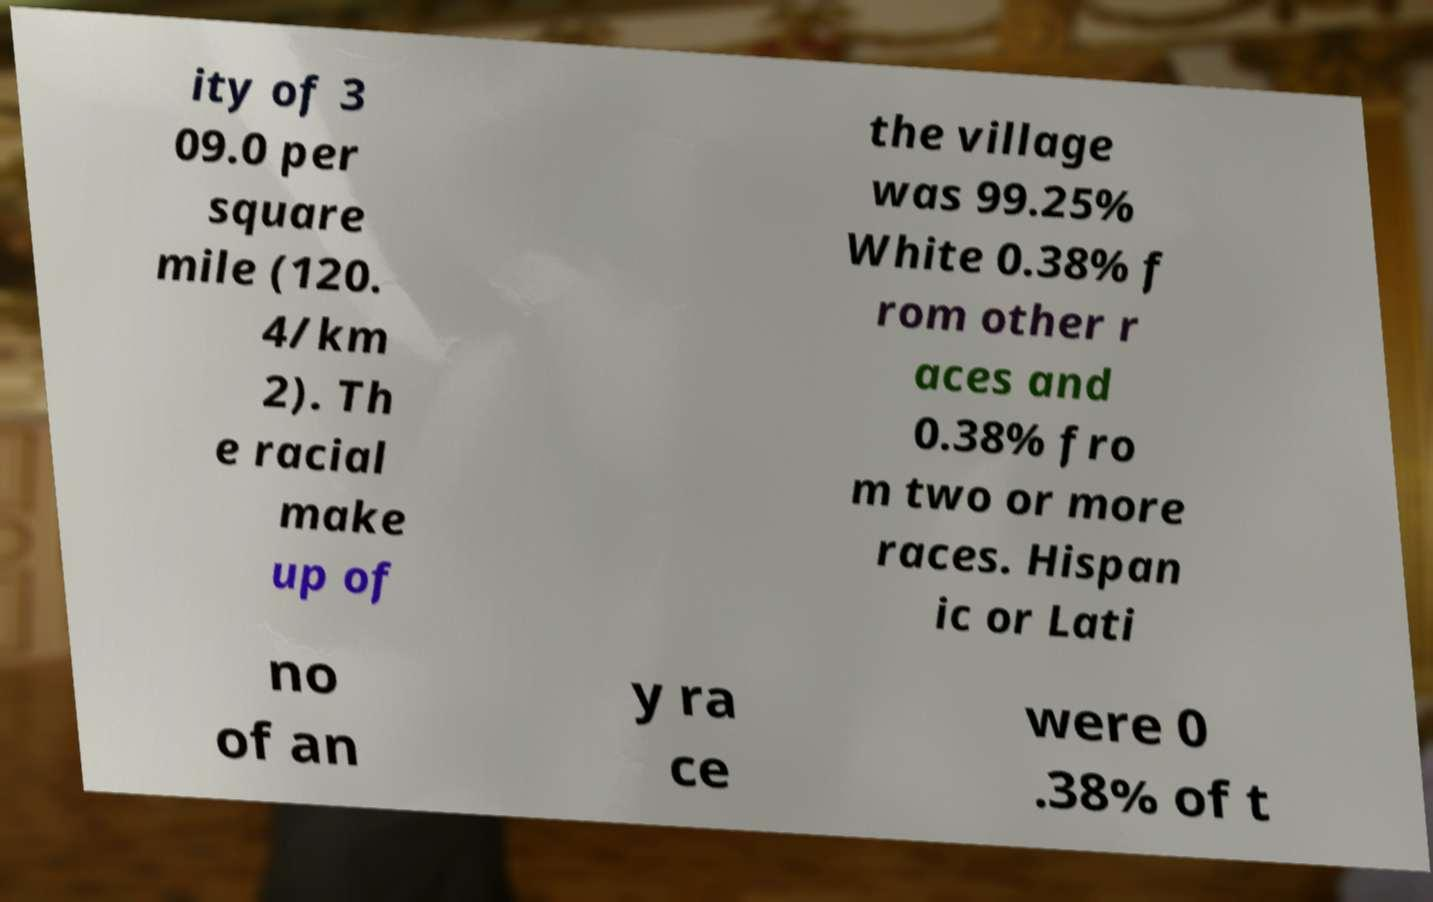Could you assist in decoding the text presented in this image and type it out clearly? ity of 3 09.0 per square mile (120. 4/km 2). Th e racial make up of the village was 99.25% White 0.38% f rom other r aces and 0.38% fro m two or more races. Hispan ic or Lati no of an y ra ce were 0 .38% of t 